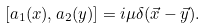Convert formula to latex. <formula><loc_0><loc_0><loc_500><loc_500>[ a _ { 1 } ( x ) , a _ { 2 } ( y ) ] = i { \mu } \delta ( \vec { x } - \vec { y } ) .</formula> 